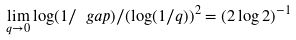Convert formula to latex. <formula><loc_0><loc_0><loc_500><loc_500>\lim _ { q \to 0 } \log ( 1 / \ g a p ) / ( \log ( 1 / q ) ) ^ { 2 } = \left ( 2 \log 2 \right ) ^ { - 1 }</formula> 